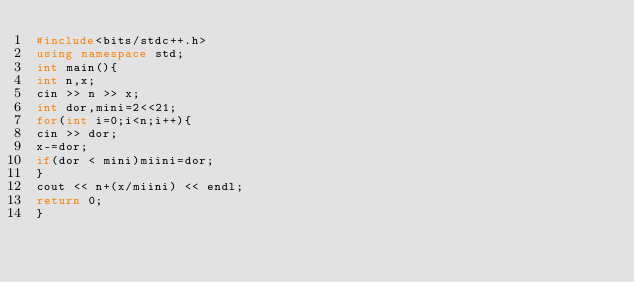<code> <loc_0><loc_0><loc_500><loc_500><_C++_>#include<bits/stdc++.h>
using namespace std;
int main(){
int n,x;
cin >> n >> x;
int dor,mini=2<<21;
for(int i=0;i<n;i++){
cin >> dor;
x-=dor;
if(dor < mini)miini=dor;
}
cout << n+(x/miini) << endl;
return 0;
} </code> 